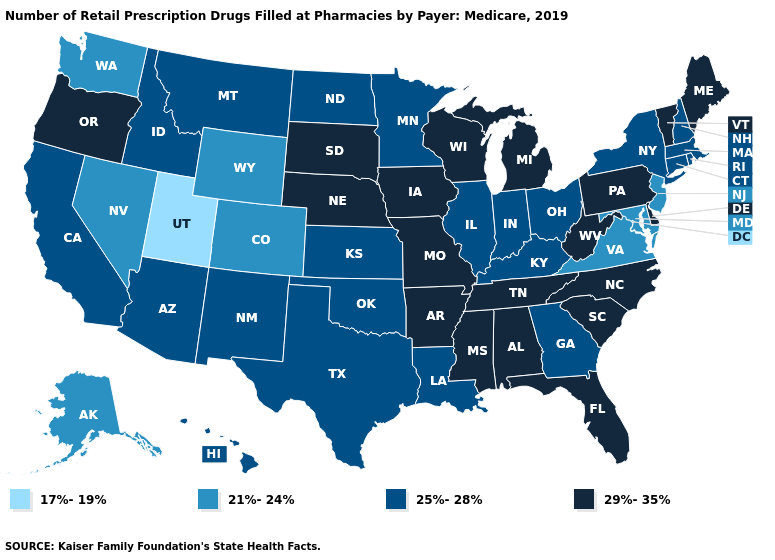What is the highest value in the South ?
Answer briefly. 29%-35%. Does New Jersey have the lowest value in the Northeast?
Short answer required. Yes. Is the legend a continuous bar?
Keep it brief. No. What is the highest value in states that border Vermont?
Concise answer only. 25%-28%. Is the legend a continuous bar?
Keep it brief. No. Among the states that border Mississippi , which have the highest value?
Be succinct. Alabama, Arkansas, Tennessee. What is the value of Illinois?
Keep it brief. 25%-28%. Does Wisconsin have the highest value in the MidWest?
Give a very brief answer. Yes. What is the value of Pennsylvania?
Answer briefly. 29%-35%. Does the map have missing data?
Keep it brief. No. Which states have the lowest value in the USA?
Quick response, please. Utah. Name the states that have a value in the range 25%-28%?
Concise answer only. Arizona, California, Connecticut, Georgia, Hawaii, Idaho, Illinois, Indiana, Kansas, Kentucky, Louisiana, Massachusetts, Minnesota, Montana, New Hampshire, New Mexico, New York, North Dakota, Ohio, Oklahoma, Rhode Island, Texas. Name the states that have a value in the range 25%-28%?
Write a very short answer. Arizona, California, Connecticut, Georgia, Hawaii, Idaho, Illinois, Indiana, Kansas, Kentucky, Louisiana, Massachusetts, Minnesota, Montana, New Hampshire, New Mexico, New York, North Dakota, Ohio, Oklahoma, Rhode Island, Texas. How many symbols are there in the legend?
Keep it brief. 4. What is the lowest value in the West?
Answer briefly. 17%-19%. 